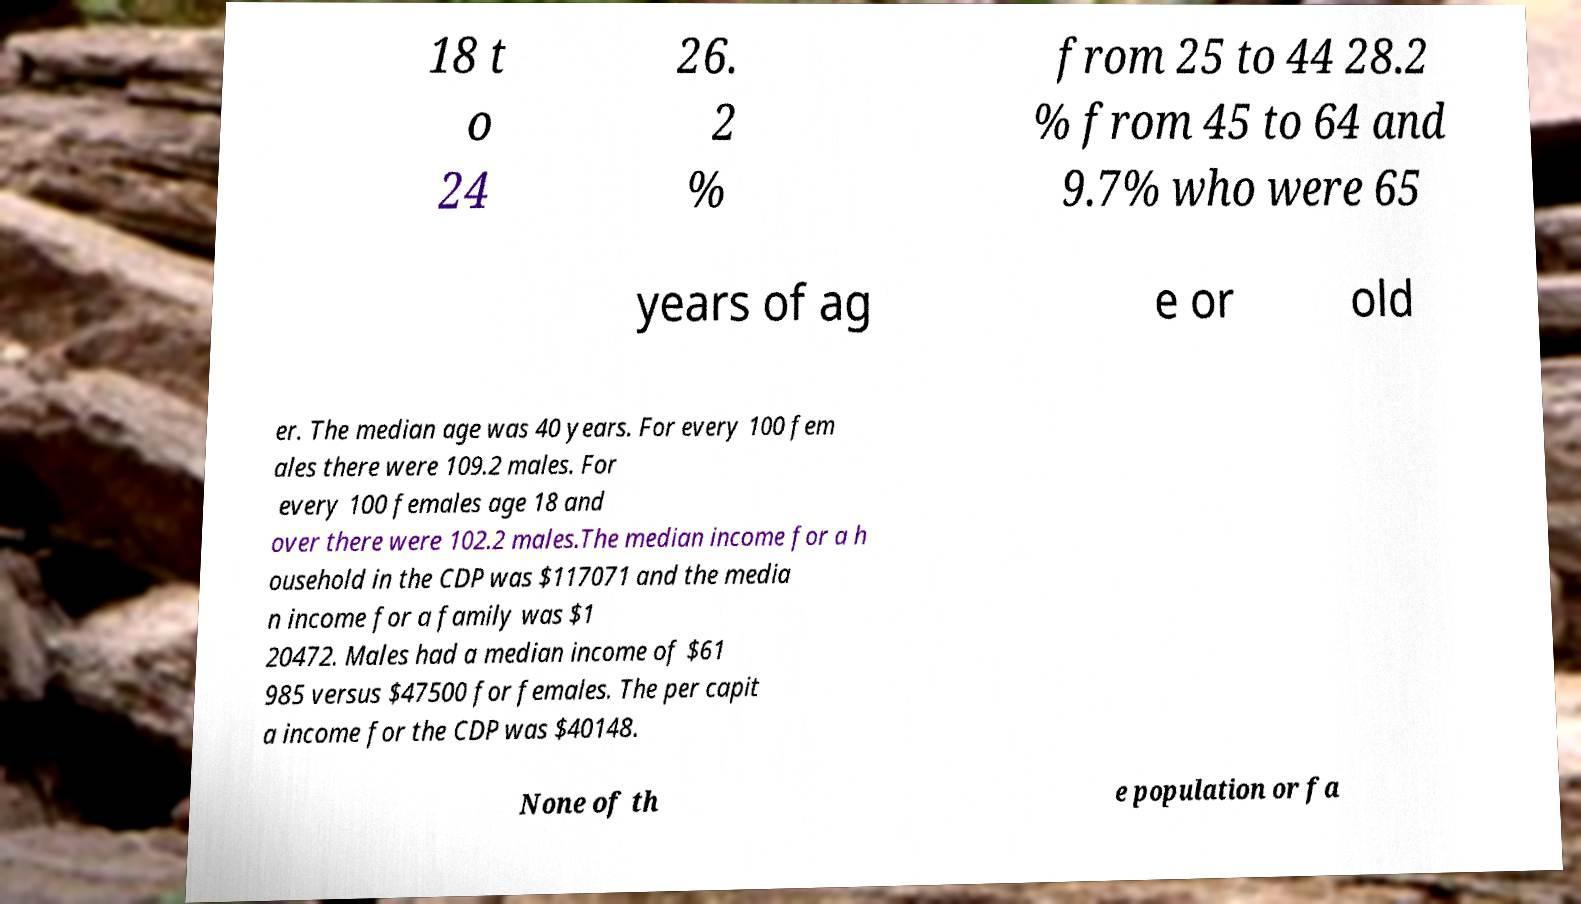There's text embedded in this image that I need extracted. Can you transcribe it verbatim? 18 t o 24 26. 2 % from 25 to 44 28.2 % from 45 to 64 and 9.7% who were 65 years of ag e or old er. The median age was 40 years. For every 100 fem ales there were 109.2 males. For every 100 females age 18 and over there were 102.2 males.The median income for a h ousehold in the CDP was $117071 and the media n income for a family was $1 20472. Males had a median income of $61 985 versus $47500 for females. The per capit a income for the CDP was $40148. None of th e population or fa 